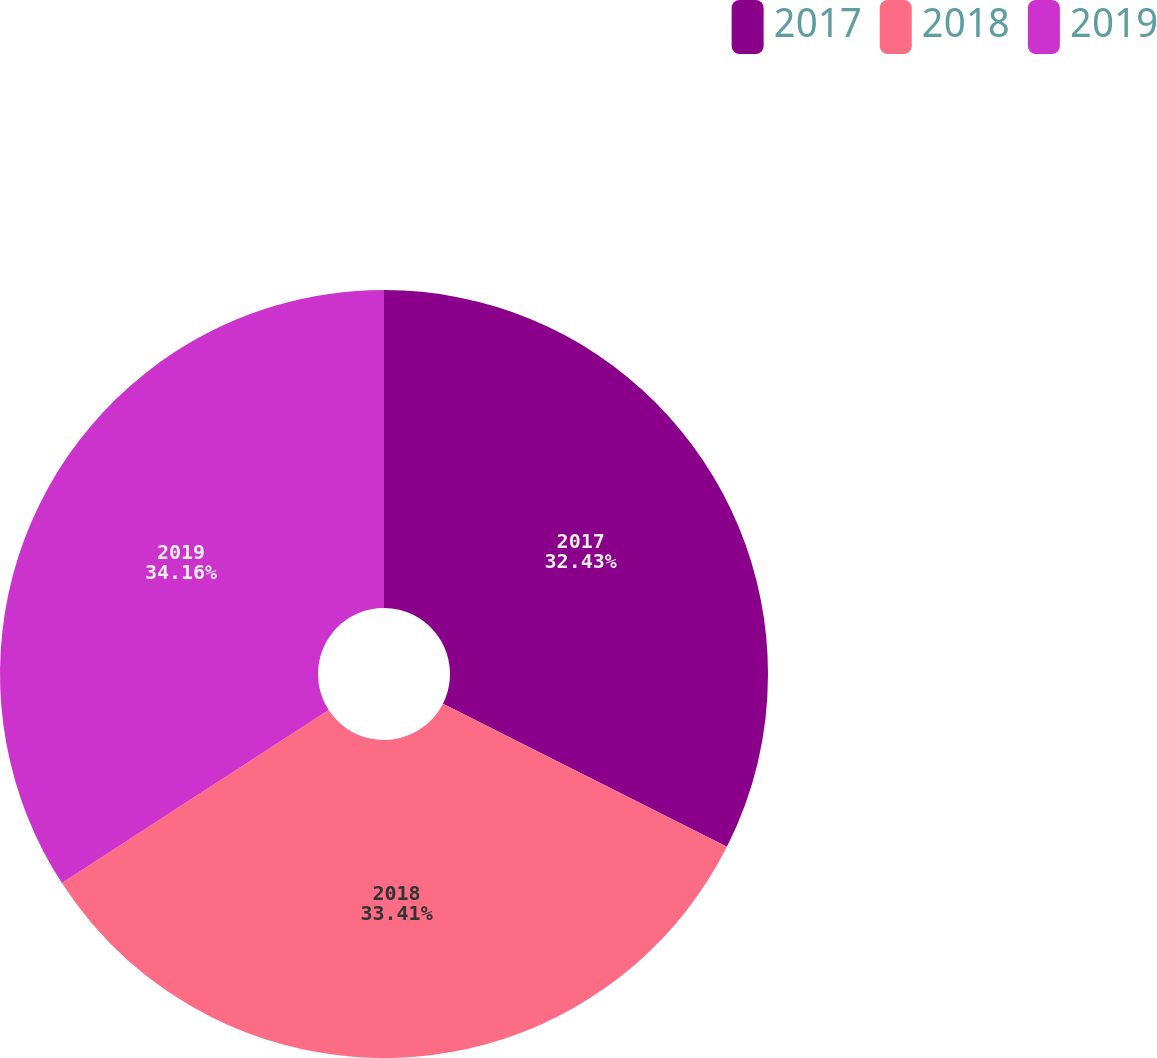<chart> <loc_0><loc_0><loc_500><loc_500><pie_chart><fcel>2017<fcel>2018<fcel>2019<nl><fcel>32.43%<fcel>33.41%<fcel>34.16%<nl></chart> 